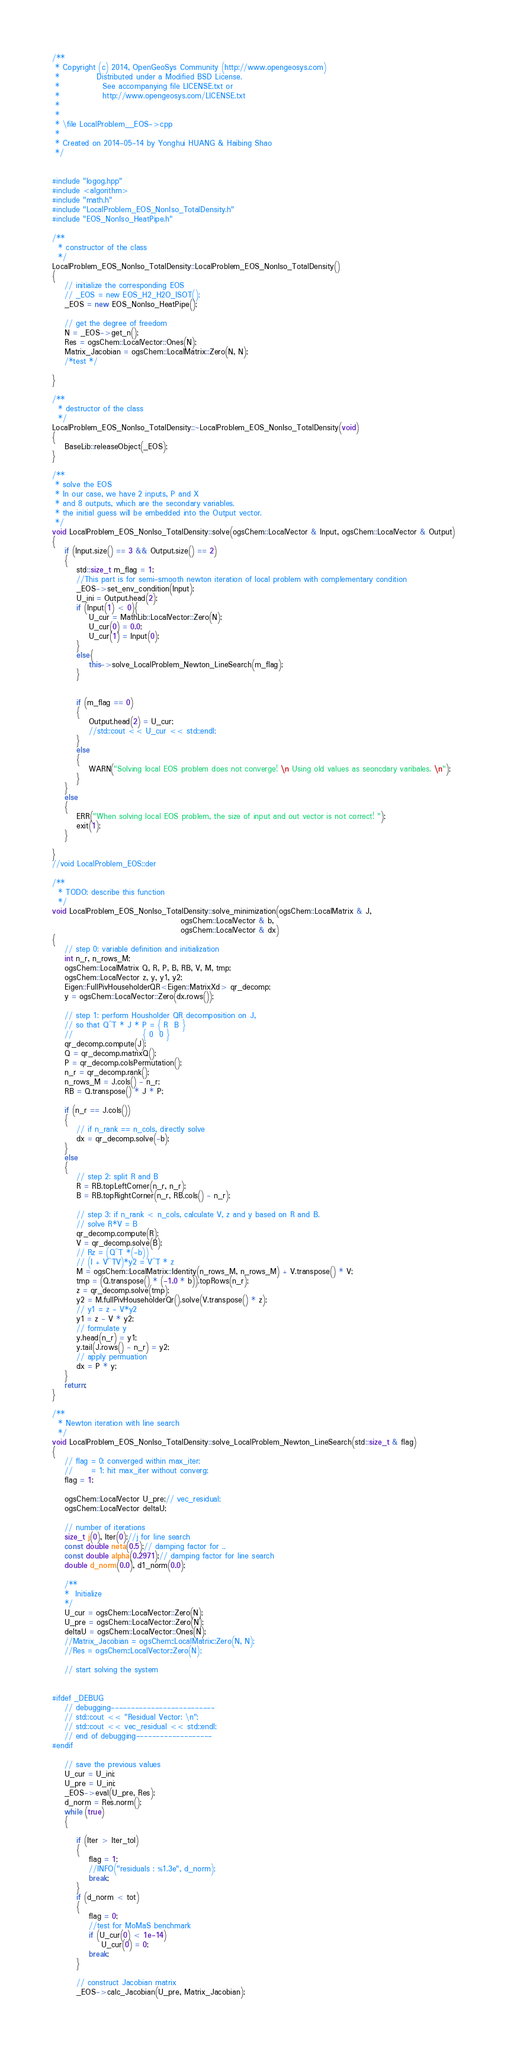<code> <loc_0><loc_0><loc_500><loc_500><_C++_>/**
 * Copyright (c) 2014, OpenGeoSys Community (http://www.opengeosys.com)
 *            Distributed under a Modified BSD License.
 *              See accompanying file LICENSE.txt or
 *              http://www.opengeosys.com/LICENSE.txt
 *
 *
 * \file LocalProblem__EOS->cpp
 *
 * Created on 2014-05-14 by Yonghui HUANG & Haibing Shao
 */


#include "logog.hpp"
#include <algorithm>
#include "math.h"
#include "LocalProblem_EOS_NonIso_TotalDensity.h"
#include "EOS_NonIso_HeatPipe.h"

/**
  * constructor of the class
  */
LocalProblem_EOS_NonIso_TotalDensity::LocalProblem_EOS_NonIso_TotalDensity()
{
	// initialize the corresponding EOS
	// _EOS = new EOS_H2_H2O_ISOT();
	_EOS = new EOS_NonIso_HeatPipe();

	// get the degree of freedom
	N = _EOS->get_n(); 
	Res = ogsChem::LocalVector::Ones(N); 
	Matrix_Jacobian = ogsChem::LocalMatrix::Zero(N, N);
	/*test */
	
}

/**
  * destructor of the class
  */
LocalProblem_EOS_NonIso_TotalDensity::~LocalProblem_EOS_NonIso_TotalDensity(void)
{
	BaseLib::releaseObject(_EOS);
}

/**
 * solve the EOS
 * In our case, we have 2 inputs, P and X
 * and 8 outputs, which are the secondary variables.
 * the initial guess will be embedded into the Output vector.
 */
void LocalProblem_EOS_NonIso_TotalDensity::solve(ogsChem::LocalVector & Input, ogsChem::LocalVector & Output)
{
	if (Input.size() == 3 && Output.size() == 2)
	{		
		std::size_t m_flag = 1; 
		//This part is for semi-smooth newton iteration of local problem with complementary condition
		_EOS->set_env_condition(Input);
		U_ini = Output.head(2);
		if (Input(1) < 0){
			U_cur = MathLib::LocalVector::Zero(N);
			U_cur(0) = 0.0;
			U_cur(1) = Input(0);
		}
		else{
			this->solve_LocalProblem_Newton_LineSearch(m_flag);
		}
		
		
		if (m_flag == 0)
		{
			Output.head(2) = U_cur;
			//std::cout << U_cur << std::endl;
		}
		else
		{
			WARN("Solving local EOS problem does not converge! \n Using old values as seoncdary varibales. \n"); 
		}
	}
	else
	{
		ERR("When solving local EOS problem, the size of input and out vector is not correct! ");
		exit(1); 
	}

}
//void LocalProblem_EOS::der

/**
  * TODO: describe this function
  */
void LocalProblem_EOS_NonIso_TotalDensity::solve_minimization(ogsChem::LocalMatrix & J,
	                                      ogsChem::LocalVector & b,
	                                      ogsChem::LocalVector & dx)
{
	// step 0: variable definition and initialization
	int n_r, n_rows_M;
	ogsChem::LocalMatrix Q, R, P, B, RB, V, M, tmp;
	ogsChem::LocalVector z, y, y1, y2;
	Eigen::FullPivHouseholderQR<Eigen::MatrixXd> qr_decomp;
	y = ogsChem::LocalVector::Zero(dx.rows());

	// step 1: perform Housholder QR decomposition on J, 
	// so that Q^T * J * P = { R  B }
	//                       { 0  0 }
	qr_decomp.compute(J);
	Q = qr_decomp.matrixQ();
	P = qr_decomp.colsPermutation();
	n_r = qr_decomp.rank();
	n_rows_M = J.cols() - n_r;
	RB = Q.transpose() * J * P;

	if (n_r == J.cols())
	{
		// if n_rank == n_cols, directly solve
		dx = qr_decomp.solve(-b);
	}
	else
	{
		// step 2: split R and B
		R = RB.topLeftCorner(n_r, n_r);
		B = RB.topRightCorner(n_r, RB.cols() - n_r);

		// step 3: if n_rank < n_cols, calculate V, z and y based on R and B. 
		// solve R*V = B
		qr_decomp.compute(R);
		V = qr_decomp.solve(B);
		// Rz = (Q^T *(-b))
		// (I + V^TV)*y2 = V^T * z
		M = ogsChem::LocalMatrix::Identity(n_rows_M, n_rows_M) + V.transpose() * V;
		tmp = (Q.transpose() * (-1.0 * b)).topRows(n_r);
		z = qr_decomp.solve(tmp);
		y2 = M.fullPivHouseholderQr().solve(V.transpose() * z);
		// y1 = z - V*y2
		y1 = z - V * y2;
		// formulate y
		y.head(n_r) = y1;
		y.tail(J.rows() - n_r) = y2;
		// apply permuation
		dx = P * y;
	}
	return;
}

/**
  * Newton iteration with line search
  */
void LocalProblem_EOS_NonIso_TotalDensity::solve_LocalProblem_Newton_LineSearch(std::size_t & flag)
{
	// flag = 0: converged within max_iter; 
	//      = 1: hit max_iter without converg;
	flag = 1; 

	ogsChem::LocalVector U_pre;// vec_residual;
	ogsChem::LocalVector deltaU;

	// number of iterations
	size_t j(0), Iter(0);//j for line search
	const double neta(0.5);// damping factor for ..
	const double alpha(0.2971);// damping factor for line search
	double d_norm(0.0), d1_norm(0.0);

	/**
	*  Initialize
	*/
	U_cur = ogsChem::LocalVector::Zero(N);
	U_pre = ogsChem::LocalVector::Zero(N);
	deltaU = ogsChem::LocalVector::Ones(N);
	//Matrix_Jacobian = ogsChem::LocalMatrix::Zero(N, N);
	//Res = ogsChem::LocalVector::Zero(N);

	// start solving the system


#ifdef _DEBUG
	// debugging--------------------------
	// std::cout << "Residual Vector: \n";
	// std::cout << vec_residual << std::endl;
	// end of debugging-------------------
#endif

	// save the previous values
	U_cur = U_ini;
	U_pre = U_ini;
	_EOS->eval(U_pre, Res);
	d_norm = Res.norm();
	while (true)
	{

		if (Iter > Iter_tol)
		{
			flag = 1;
			//INFO("residuals : %1.3e", d_norm);
			break; 
		}
		if (d_norm < tot)
		{
			flag = 0; 
			//test for MoMaS benchmark 
			if (U_cur(0) < 1e-14)
				U_cur(0) = 0;
			break; 
		}

		// construct Jacobian matrix
		_EOS->calc_Jacobian(U_pre, Matrix_Jacobian);</code> 